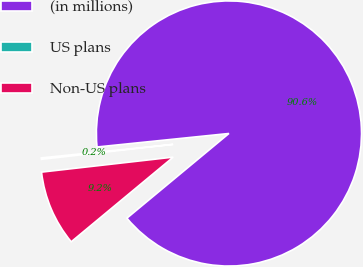<chart> <loc_0><loc_0><loc_500><loc_500><pie_chart><fcel>(in millions)<fcel>US plans<fcel>Non-US plans<nl><fcel>90.6%<fcel>0.18%<fcel>9.22%<nl></chart> 